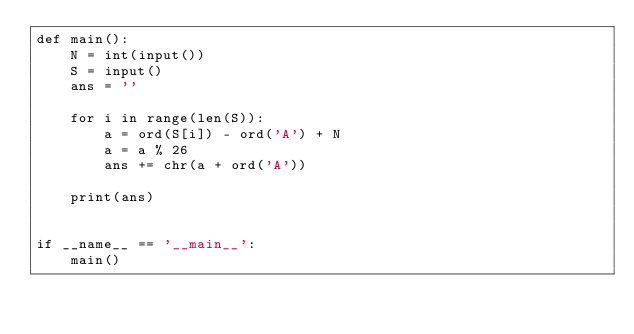<code> <loc_0><loc_0><loc_500><loc_500><_Python_>def main():
    N = int(input())
    S = input()
    ans = ''

    for i in range(len(S)):
        a = ord(S[i]) - ord('A') + N
        a = a % 26
        ans += chr(a + ord('A'))

    print(ans)


if __name__ == '__main__':
    main()
</code> 